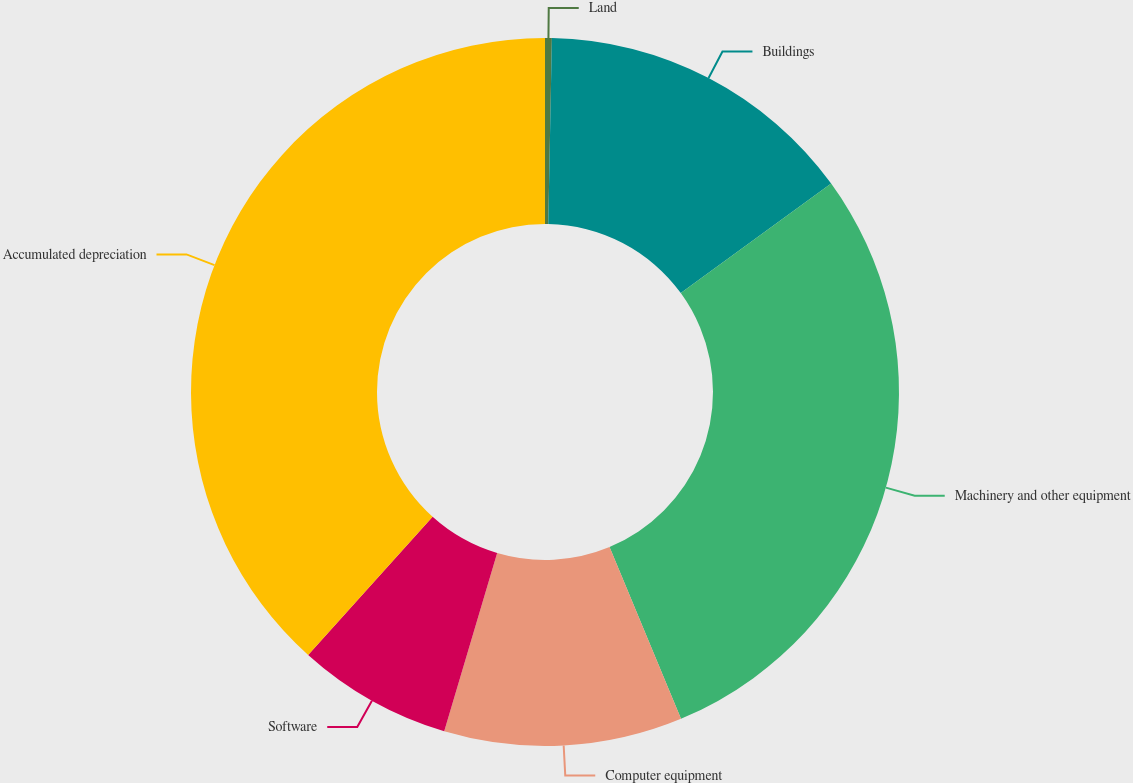Convert chart to OTSL. <chart><loc_0><loc_0><loc_500><loc_500><pie_chart><fcel>Land<fcel>Buildings<fcel>Machinery and other equipment<fcel>Computer equipment<fcel>Software<fcel>Accumulated depreciation<nl><fcel>0.31%<fcel>14.67%<fcel>28.74%<fcel>10.87%<fcel>7.07%<fcel>38.33%<nl></chart> 